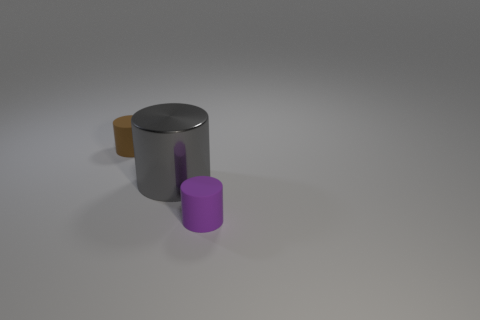Is there any other thing that has the same size as the metallic cylinder?
Provide a succinct answer. No. Are there fewer cylinders that are on the right side of the brown thing than gray cylinders that are left of the big gray cylinder?
Give a very brief answer. No. The other tiny object that is the same shape as the tiny brown object is what color?
Provide a short and direct response. Purple. The purple cylinder is what size?
Your response must be concise. Small. What number of brown cylinders have the same size as the metallic thing?
Your response must be concise. 0. Does the tiny cylinder that is left of the purple cylinder have the same material as the small thing that is in front of the brown matte object?
Provide a succinct answer. Yes. Is the number of purple things greater than the number of cylinders?
Provide a succinct answer. No. Is there any other thing that has the same color as the metallic cylinder?
Make the answer very short. No. Is the material of the brown object the same as the large object?
Your answer should be compact. No. Is the number of tiny things less than the number of large gray objects?
Give a very brief answer. No. 